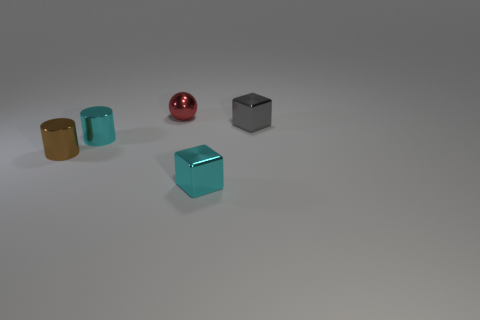What number of brown cylinders have the same size as the cyan metal cube?
Make the answer very short. 1. Do the cyan thing right of the red object and the cyan metal thing that is left of the tiny metallic ball have the same size?
Keep it short and to the point. Yes. What is the shape of the cyan metal thing to the left of the cyan block?
Provide a short and direct response. Cylinder. What is the material of the small ball behind the tiny cylinder that is in front of the cyan cylinder?
Your response must be concise. Metal. Is there a shiny cylinder that has the same color as the shiny ball?
Your response must be concise. No. Is the size of the brown cylinder the same as the metallic cube that is behind the small cyan shiny cylinder?
Your response must be concise. Yes. How many blocks are behind the cyan metal thing behind the tiny shiny object left of the cyan metallic cylinder?
Provide a succinct answer. 1. What number of tiny brown shiny things are behind the tiny gray cube?
Your response must be concise. 0. The small shiny cube that is in front of the tiny cyan object that is left of the red metallic ball is what color?
Your answer should be very brief. Cyan. What number of other objects are there of the same material as the cyan cylinder?
Give a very brief answer. 4. 